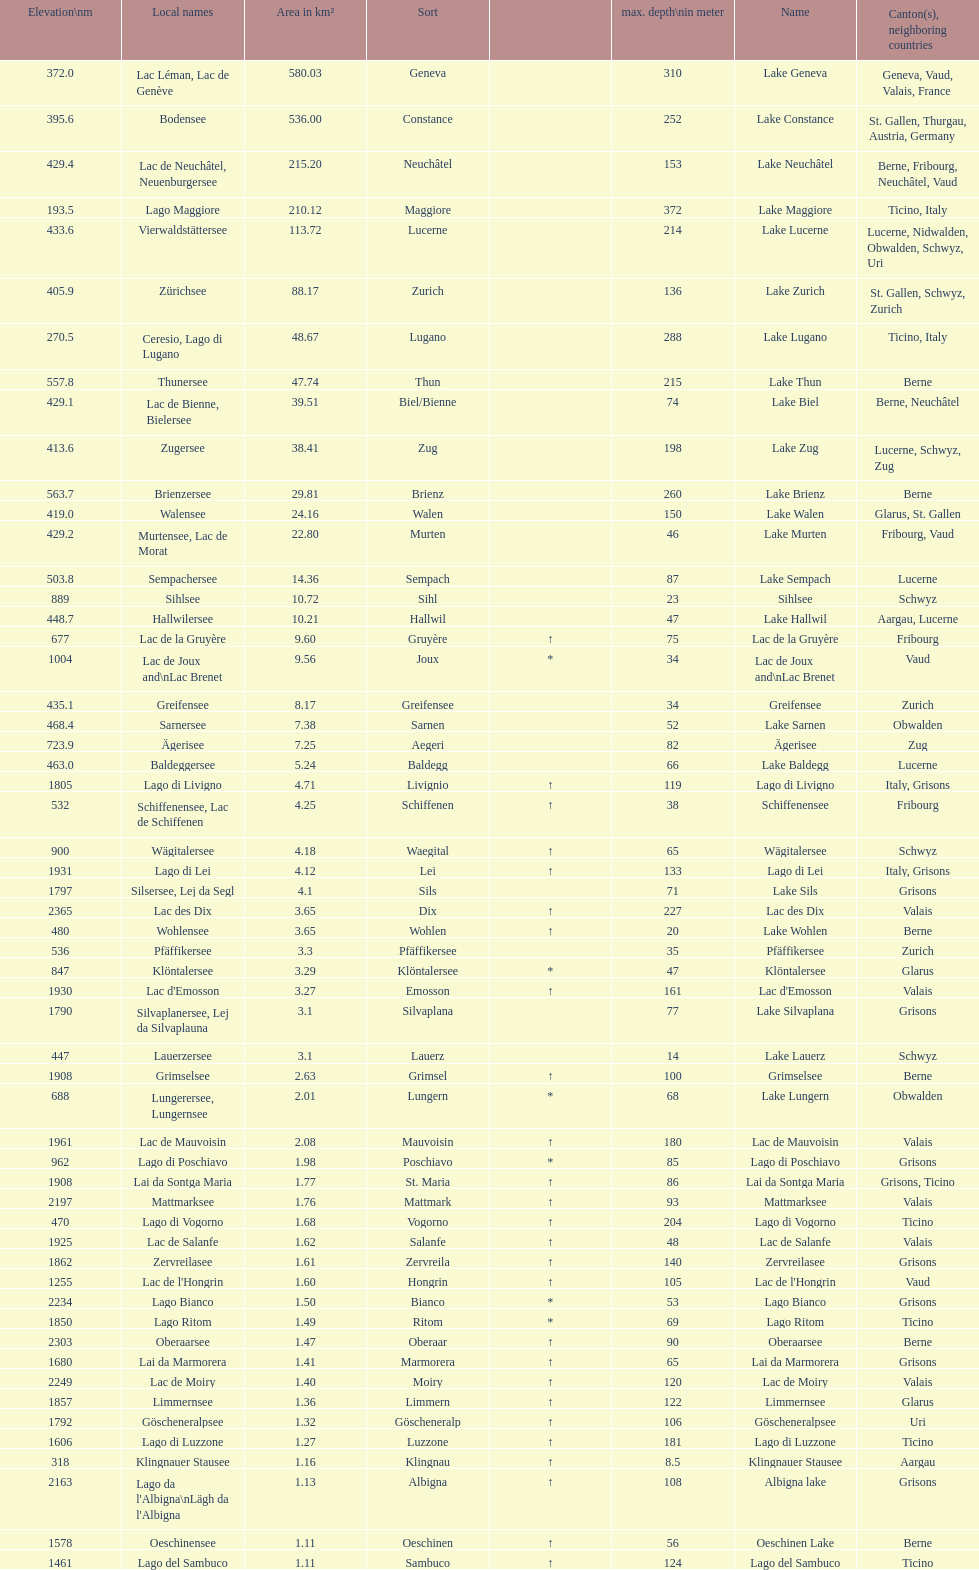I'm looking to parse the entire table for insights. Could you assist me with that? {'header': ['Elevation\\nm', 'Local names', 'Area in km²', 'Sort', '', 'max. depth\\nin meter', 'Name', 'Canton(s), neighboring countries'], 'rows': [['372.0', 'Lac Léman, Lac de Genève', '580.03', 'Geneva', '', '310', 'Lake Geneva', 'Geneva, Vaud, Valais, France'], ['395.6', 'Bodensee', '536.00', 'Constance', '', '252', 'Lake Constance', 'St. Gallen, Thurgau, Austria, Germany'], ['429.4', 'Lac de Neuchâtel, Neuenburgersee', '215.20', 'Neuchâtel', '', '153', 'Lake Neuchâtel', 'Berne, Fribourg, Neuchâtel, Vaud'], ['193.5', 'Lago Maggiore', '210.12', 'Maggiore', '', '372', 'Lake Maggiore', 'Ticino, Italy'], ['433.6', 'Vierwaldstättersee', '113.72', 'Lucerne', '', '214', 'Lake Lucerne', 'Lucerne, Nidwalden, Obwalden, Schwyz, Uri'], ['405.9', 'Zürichsee', '88.17', 'Zurich', '', '136', 'Lake Zurich', 'St. Gallen, Schwyz, Zurich'], ['270.5', 'Ceresio, Lago di Lugano', '48.67', 'Lugano', '', '288', 'Lake Lugano', 'Ticino, Italy'], ['557.8', 'Thunersee', '47.74', 'Thun', '', '215', 'Lake Thun', 'Berne'], ['429.1', 'Lac de Bienne, Bielersee', '39.51', 'Biel/Bienne', '', '74', 'Lake Biel', 'Berne, Neuchâtel'], ['413.6', 'Zugersee', '38.41', 'Zug', '', '198', 'Lake Zug', 'Lucerne, Schwyz, Zug'], ['563.7', 'Brienzersee', '29.81', 'Brienz', '', '260', 'Lake Brienz', 'Berne'], ['419.0', 'Walensee', '24.16', 'Walen', '', '150', 'Lake Walen', 'Glarus, St. Gallen'], ['429.2', 'Murtensee, Lac de Morat', '22.80', 'Murten', '', '46', 'Lake Murten', 'Fribourg, Vaud'], ['503.8', 'Sempachersee', '14.36', 'Sempach', '', '87', 'Lake Sempach', 'Lucerne'], ['889', 'Sihlsee', '10.72', 'Sihl', '', '23', 'Sihlsee', 'Schwyz'], ['448.7', 'Hallwilersee', '10.21', 'Hallwil', '', '47', 'Lake Hallwil', 'Aargau, Lucerne'], ['677', 'Lac de la Gruyère', '9.60', 'Gruyère', '↑', '75', 'Lac de la Gruyère', 'Fribourg'], ['1004', 'Lac de Joux and\\nLac Brenet', '9.56', 'Joux', '*', '34', 'Lac de Joux and\\nLac Brenet', 'Vaud'], ['435.1', 'Greifensee', '8.17', 'Greifensee', '', '34', 'Greifensee', 'Zurich'], ['468.4', 'Sarnersee', '7.38', 'Sarnen', '', '52', 'Lake Sarnen', 'Obwalden'], ['723.9', 'Ägerisee', '7.25', 'Aegeri', '', '82', 'Ägerisee', 'Zug'], ['463.0', 'Baldeggersee', '5.24', 'Baldegg', '', '66', 'Lake Baldegg', 'Lucerne'], ['1805', 'Lago di Livigno', '4.71', 'Livignio', '↑', '119', 'Lago di Livigno', 'Italy, Grisons'], ['532', 'Schiffenensee, Lac de Schiffenen', '4.25', 'Schiffenen', '↑', '38', 'Schiffenensee', 'Fribourg'], ['900', 'Wägitalersee', '4.18', 'Waegital', '↑', '65', 'Wägitalersee', 'Schwyz'], ['1931', 'Lago di Lei', '4.12', 'Lei', '↑', '133', 'Lago di Lei', 'Italy, Grisons'], ['1797', 'Silsersee, Lej da Segl', '4.1', 'Sils', '', '71', 'Lake Sils', 'Grisons'], ['2365', 'Lac des Dix', '3.65', 'Dix', '↑', '227', 'Lac des Dix', 'Valais'], ['480', 'Wohlensee', '3.65', 'Wohlen', '↑', '20', 'Lake Wohlen', 'Berne'], ['536', 'Pfäffikersee', '3.3', 'Pfäffikersee', '', '35', 'Pfäffikersee', 'Zurich'], ['847', 'Klöntalersee', '3.29', 'Klöntalersee', '*', '47', 'Klöntalersee', 'Glarus'], ['1930', "Lac d'Emosson", '3.27', 'Emosson', '↑', '161', "Lac d'Emosson", 'Valais'], ['1790', 'Silvaplanersee, Lej da Silvaplauna', '3.1', 'Silvaplana', '', '77', 'Lake Silvaplana', 'Grisons'], ['447', 'Lauerzersee', '3.1', 'Lauerz', '', '14', 'Lake Lauerz', 'Schwyz'], ['1908', 'Grimselsee', '2.63', 'Grimsel', '↑', '100', 'Grimselsee', 'Berne'], ['688', 'Lungerersee, Lungernsee', '2.01', 'Lungern', '*', '68', 'Lake Lungern', 'Obwalden'], ['1961', 'Lac de Mauvoisin', '2.08', 'Mauvoisin', '↑', '180', 'Lac de Mauvoisin', 'Valais'], ['962', 'Lago di Poschiavo', '1.98', 'Poschiavo', '*', '85', 'Lago di Poschiavo', 'Grisons'], ['1908', 'Lai da Sontga Maria', '1.77', 'St. Maria', '↑', '86', 'Lai da Sontga Maria', 'Grisons, Ticino'], ['2197', 'Mattmarksee', '1.76', 'Mattmark', '↑', '93', 'Mattmarksee', 'Valais'], ['470', 'Lago di Vogorno', '1.68', 'Vogorno', '↑', '204', 'Lago di Vogorno', 'Ticino'], ['1925', 'Lac de Salanfe', '1.62', 'Salanfe', '↑', '48', 'Lac de Salanfe', 'Valais'], ['1862', 'Zervreilasee', '1.61', 'Zervreila', '↑', '140', 'Zervreilasee', 'Grisons'], ['1255', "Lac de l'Hongrin", '1.60', 'Hongrin', '↑', '105', "Lac de l'Hongrin", 'Vaud'], ['2234', 'Lago Bianco', '1.50', 'Bianco', '*', '53', 'Lago Bianco', 'Grisons'], ['1850', 'Lago Ritom', '1.49', 'Ritom', '*', '69', 'Lago Ritom', 'Ticino'], ['2303', 'Oberaarsee', '1.47', 'Oberaar', '↑', '90', 'Oberaarsee', 'Berne'], ['1680', 'Lai da Marmorera', '1.41', 'Marmorera', '↑', '65', 'Lai da Marmorera', 'Grisons'], ['2249', 'Lac de Moiry', '1.40', 'Moiry', '↑', '120', 'Lac de Moiry', 'Valais'], ['1857', 'Limmernsee', '1.36', 'Limmern', '↑', '122', 'Limmernsee', 'Glarus'], ['1792', 'Göscheneralpsee', '1.32', 'Göscheneralp', '↑', '106', 'Göscheneralpsee', 'Uri'], ['1606', 'Lago di Luzzone', '1.27', 'Luzzone', '↑', '181', 'Lago di Luzzone', 'Ticino'], ['318', 'Klingnauer Stausee', '1.16', 'Klingnau', '↑', '8.5', 'Klingnauer Stausee', 'Aargau'], ['2163', "Lago da l'Albigna\\nLägh da l'Albigna", '1.13', 'Albigna', '↑', '108', 'Albigna lake', 'Grisons'], ['1578', 'Oeschinensee', '1.11', 'Oeschinen', '↑', '56', 'Oeschinen Lake', 'Berne'], ['1461', 'Lago del Sambuco', '1.11', 'Sambuco', '↑', '124', 'Lago del Sambuco', 'Ticino']]} Which is the only lake with a max depth of 372m? Lake Maggiore. 